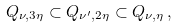Convert formula to latex. <formula><loc_0><loc_0><loc_500><loc_500>Q _ { \nu , 3 \eta } \subset Q _ { \nu ^ { \prime } , 2 \eta } \subset Q _ { \nu , \eta } \, ,</formula> 